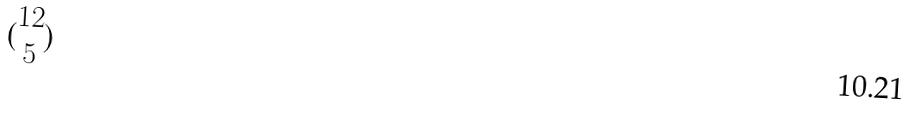Convert formula to latex. <formula><loc_0><loc_0><loc_500><loc_500>( \begin{matrix} 1 2 \\ 5 \end{matrix} )</formula> 